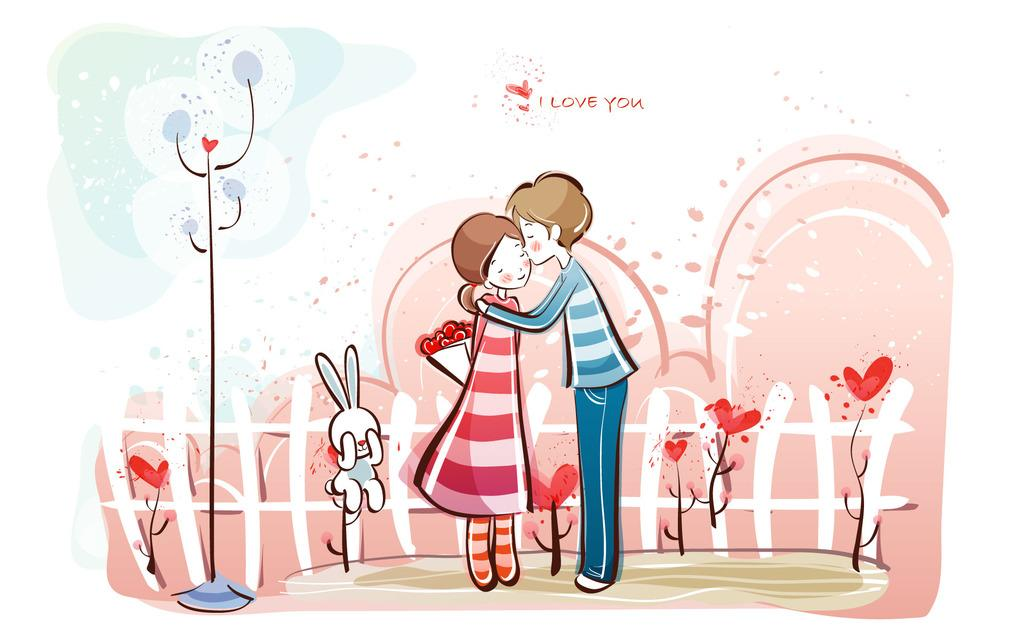What type of characters are depicted in the image? There is a cartoon picture of a man and a cartoon picture of a woman in the image. What else can be seen in the image besides the characters? There is text visible in the image. Can you describe the other unspecified elements in the image? Unfortunately, the facts provided do not specify the nature of the other elements in the image. Where is the drain located in the image? There is no drain present in the image. What type of nest can be seen in the image? There is no nest present in the image. 